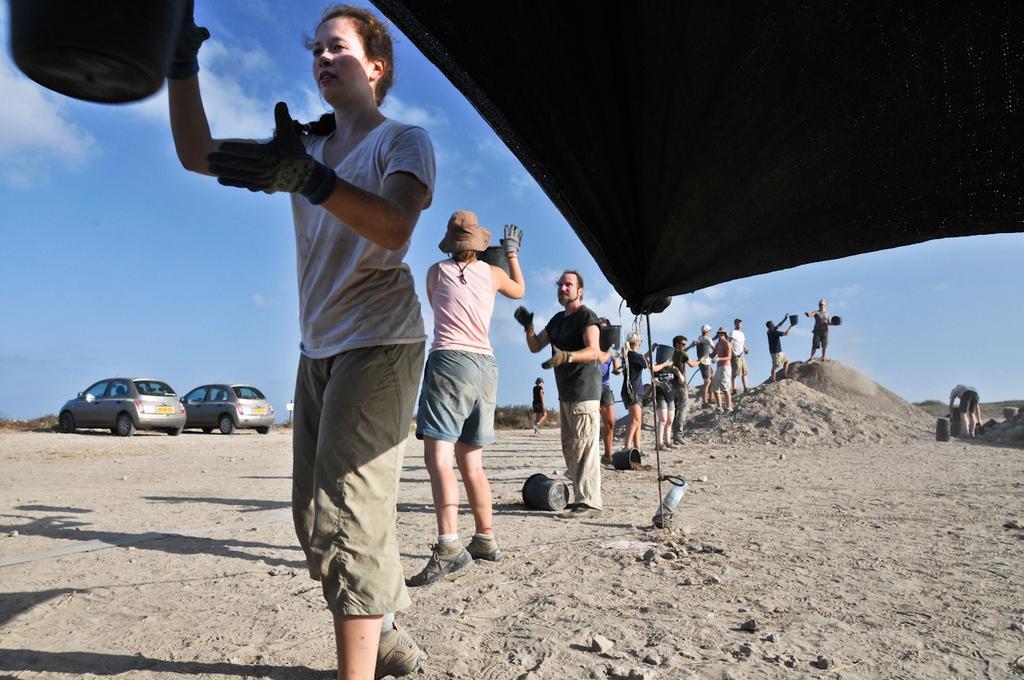In one or two sentences, can you explain what this image depicts? In this image at the top there is the tent, on the land there are few persons standing in a line passing buckets, on the right side there is a person bending , on the land there are some objects, a person walking, soil, at the top there is the sky. 